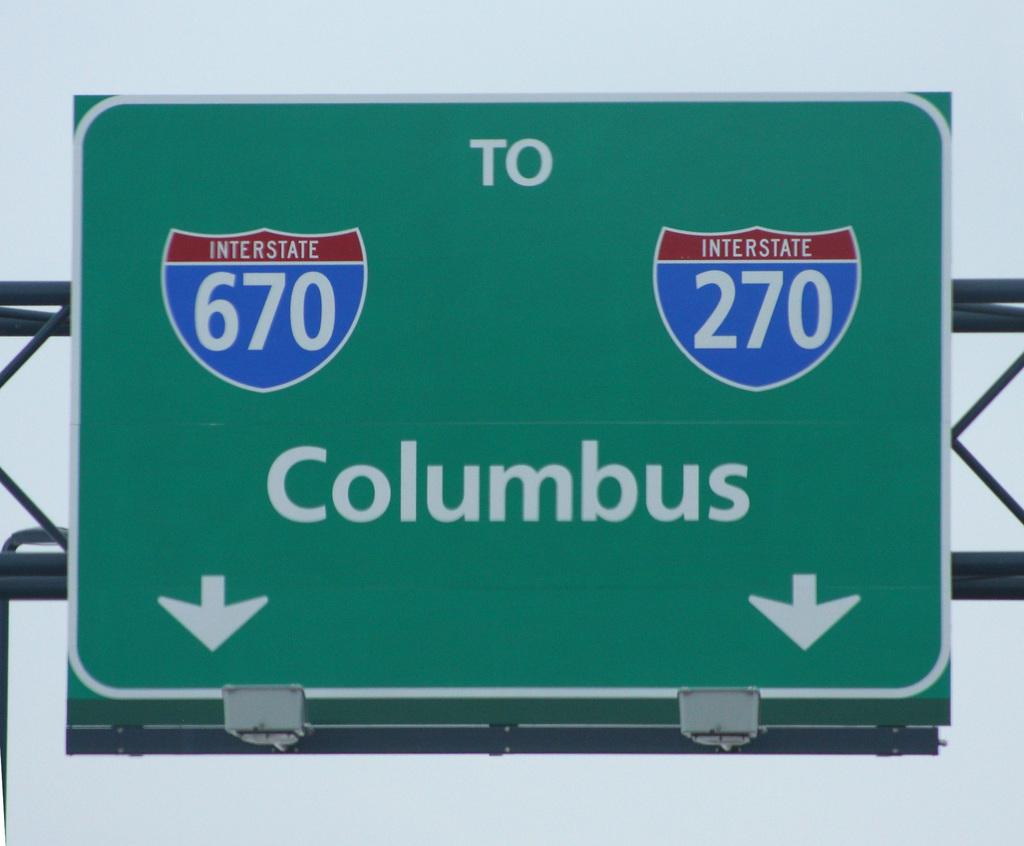What interstate can i take?
Provide a short and direct response. 670 or 270. What city is this going to?
Offer a terse response. Columbus. 